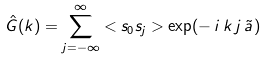<formula> <loc_0><loc_0><loc_500><loc_500>\hat { G } ( k ) = \sum ^ { \infty } _ { j = - \infty } < s _ { 0 } s _ { j } > \exp ( - \, i \, k \, j \, \tilde { a } \, )</formula> 